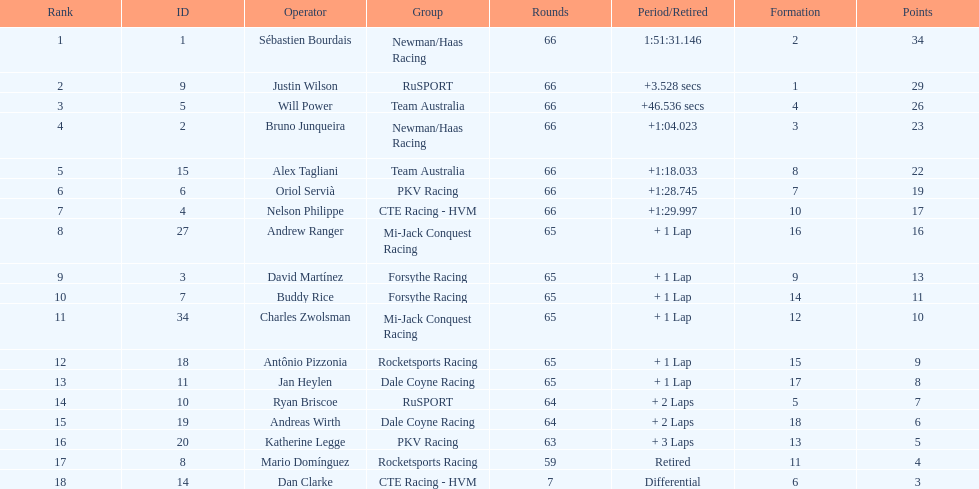Which country had more drivers representing them, the us or germany? Tie. 